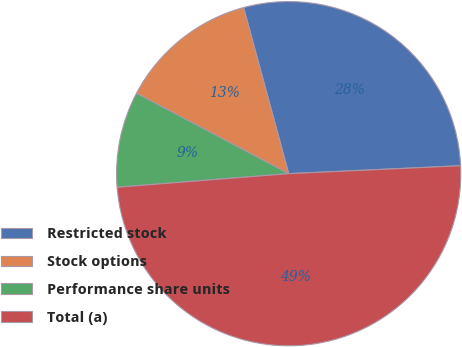Convert chart to OTSL. <chart><loc_0><loc_0><loc_500><loc_500><pie_chart><fcel>Restricted stock<fcel>Stock options<fcel>Performance share units<fcel>Total (a)<nl><fcel>28.49%<fcel>13.04%<fcel>9.0%<fcel>49.48%<nl></chart> 